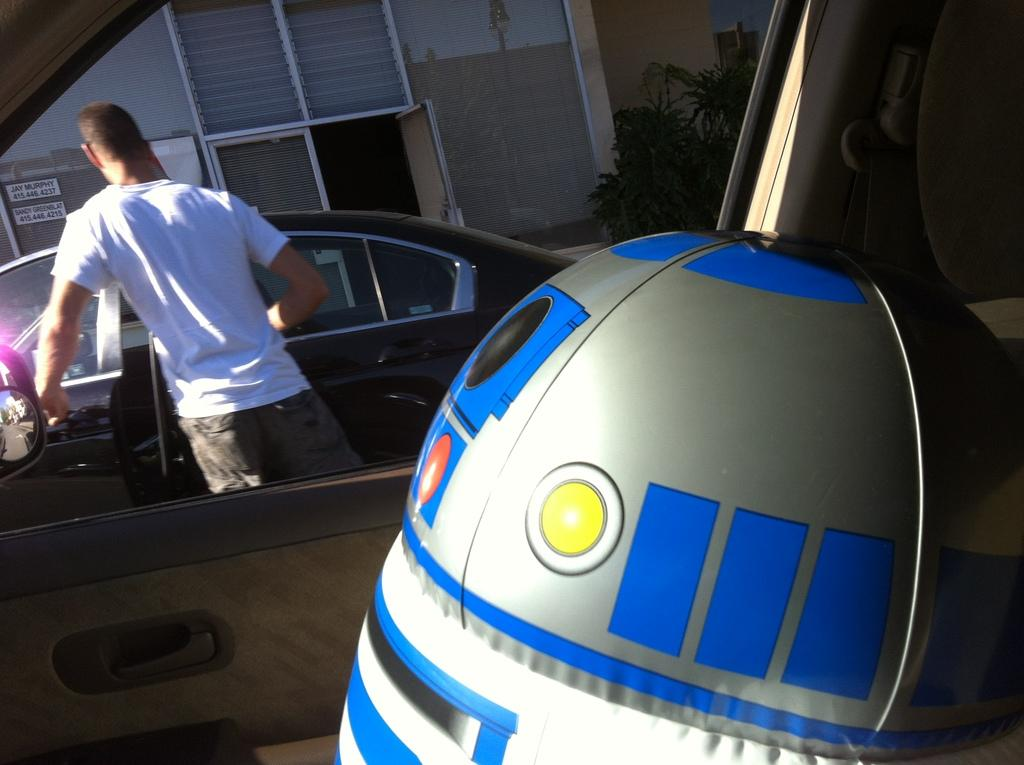What is inside the vehicle in the image? There is an object inside a vehicle in the image. Can you describe the person visible in the image? There is a person visible in the image. How many other vehicles can be seen in the image? There are other vehicles in the image. What type of vegetation is visible in the background of the image? There are plants in the background of the image. What type of building is visible in the background of the image? There is a building with boards in the background of the image. What type of feast is being prepared by the governor in the image? There is no governor or feast present in the image. What type of paper is being used by the person in the image? There is no paper visible in the image. 